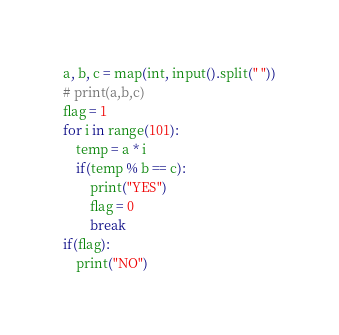Convert code to text. <code><loc_0><loc_0><loc_500><loc_500><_Python_>a, b, c = map(int, input().split(" "))
# print(a,b,c)
flag = 1
for i in range(101):
    temp = a * i
    if(temp % b == c):
        print("YES")
        flag = 0
        break
if(flag):
    print("NO")</code> 